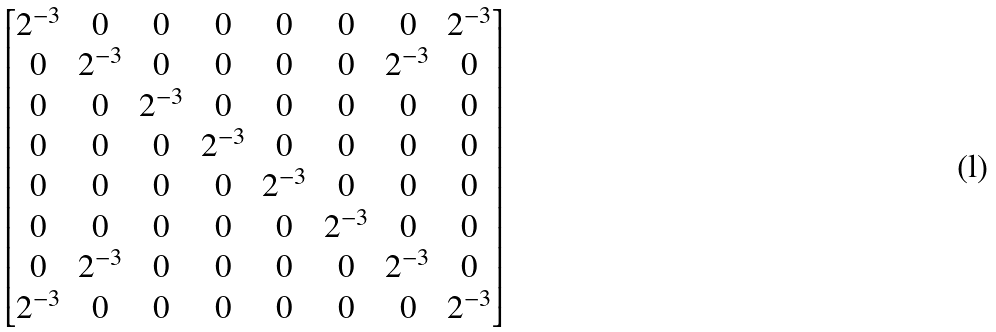Convert formula to latex. <formula><loc_0><loc_0><loc_500><loc_500>\begin{bmatrix} 2 ^ { - 3 } & 0 & 0 & 0 & 0 & 0 & 0 & 2 ^ { - 3 } \\ 0 & 2 ^ { - 3 } & 0 & 0 & 0 & 0 & 2 ^ { - 3 } & 0 \\ 0 & 0 & 2 ^ { - 3 } & 0 & 0 & 0 & 0 & 0 \\ 0 & 0 & 0 & 2 ^ { - 3 } & 0 & 0 & 0 & 0 \\ 0 & 0 & 0 & 0 & 2 ^ { - 3 } & 0 & 0 & 0 \\ 0 & 0 & 0 & 0 & 0 & 2 ^ { - 3 } & 0 & 0 \\ 0 & 2 ^ { - 3 } & 0 & 0 & 0 & 0 & 2 ^ { - 3 } & 0 \\ 2 ^ { - 3 } & 0 & 0 & 0 & 0 & 0 & 0 & 2 ^ { - 3 } \\ \end{bmatrix}</formula> 